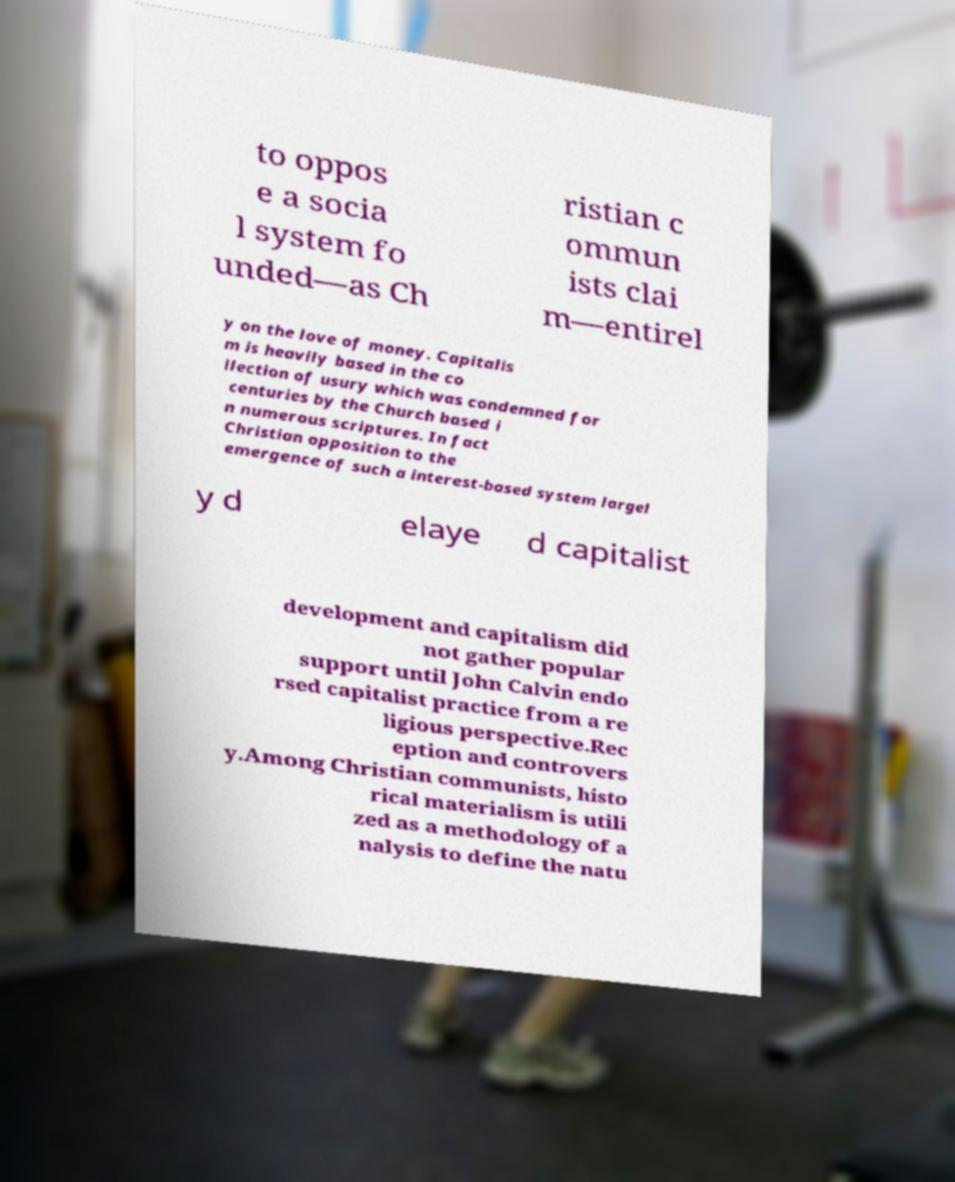I need the written content from this picture converted into text. Can you do that? to oppos e a socia l system fo unded—as Ch ristian c ommun ists clai m—entirel y on the love of money. Capitalis m is heavily based in the co llection of usury which was condemned for centuries by the Church based i n numerous scriptures. In fact Christian opposition to the emergence of such a interest-based system largel y d elaye d capitalist development and capitalism did not gather popular support until John Calvin endo rsed capitalist practice from a re ligious perspective.Rec eption and controvers y.Among Christian communists, histo rical materialism is utili zed as a methodology of a nalysis to define the natu 